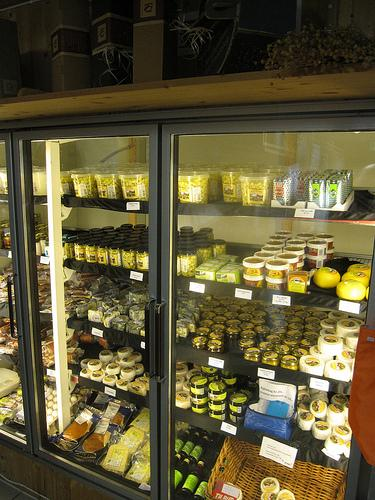Identify a complex reasoning question related to the image and provide an answer to it. The customer would need to access the sections containing cheeses, eggs, glass jars, containers of goods, sandwiches, and bundles of packages. Identify the main focus in the image and describe its appearance. The main focus is a fridge filled with various types of food, including cheeses, eggs, glass jars, and containers of goods. What kind of sentiment is evoked by the image? The image evokes a sentiment of variety and abundance, as there are many different types of food items displayed in the fridge. How many wicker baskets are present in the image and what is inside them? There are two wicker baskets present. One contains small items, while the other contains cheeses. Estimate the number of different types of products available in the fridge. There are approximately 15-20 different types of products in the fridge. Describe the interactions between the various food items in the fridge. The food items are neatly arranged in specific sections of the fridge, with similar types of items grouped together for easy identification and selection. Analyze the image from a visual question answering perspective and describe the most interesting aspect. The most interesting aspect is the well-organized arrangement of diverse food items in the fridge, which allows for easy access and selection for the customers. Count the number of cooler door handles that are present in the image. There are two black cooler door handles in the image. List three types of items you can find in the fridge. Yellow and white cheeses, eggs, and readymade sandwiches wrapped in plastic. Determine the quality of the image in terms of composition and arrangement of objects. The image quality is satisfactory, with a clear arrangement of the objects and good balance between the items in the fridge. 